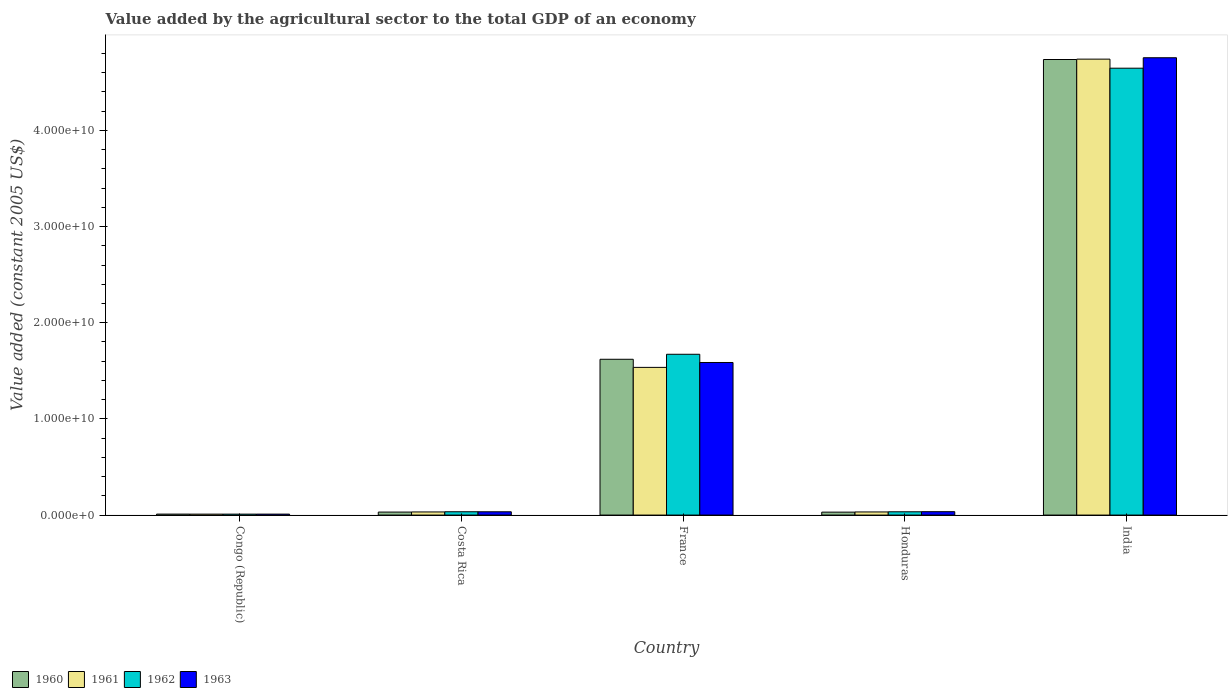Are the number of bars on each tick of the X-axis equal?
Keep it short and to the point. Yes. How many bars are there on the 1st tick from the right?
Your response must be concise. 4. What is the label of the 5th group of bars from the left?
Provide a short and direct response. India. In how many cases, is the number of bars for a given country not equal to the number of legend labels?
Give a very brief answer. 0. What is the value added by the agricultural sector in 1963 in Costa Rica?
Offer a terse response. 3.43e+08. Across all countries, what is the maximum value added by the agricultural sector in 1963?
Your answer should be compact. 4.76e+1. Across all countries, what is the minimum value added by the agricultural sector in 1962?
Offer a terse response. 9.79e+07. In which country was the value added by the agricultural sector in 1963 minimum?
Your response must be concise. Congo (Republic). What is the total value added by the agricultural sector in 1962 in the graph?
Provide a short and direct response. 6.40e+1. What is the difference between the value added by the agricultural sector in 1963 in Costa Rica and that in Honduras?
Your response must be concise. -9.78e+06. What is the difference between the value added by the agricultural sector in 1960 in Honduras and the value added by the agricultural sector in 1961 in France?
Your answer should be compact. -1.51e+1. What is the average value added by the agricultural sector in 1963 per country?
Offer a very short reply. 1.28e+1. What is the difference between the value added by the agricultural sector of/in 1962 and value added by the agricultural sector of/in 1960 in Honduras?
Provide a succinct answer. 3.54e+07. In how many countries, is the value added by the agricultural sector in 1962 greater than 6000000000 US$?
Your response must be concise. 2. What is the ratio of the value added by the agricultural sector in 1961 in France to that in Honduras?
Your answer should be very brief. 47.21. What is the difference between the highest and the second highest value added by the agricultural sector in 1960?
Offer a very short reply. 3.12e+1. What is the difference between the highest and the lowest value added by the agricultural sector in 1963?
Keep it short and to the point. 4.75e+1. In how many countries, is the value added by the agricultural sector in 1962 greater than the average value added by the agricultural sector in 1962 taken over all countries?
Your response must be concise. 2. What does the 1st bar from the left in India represents?
Keep it short and to the point. 1960. Is it the case that in every country, the sum of the value added by the agricultural sector in 1961 and value added by the agricultural sector in 1960 is greater than the value added by the agricultural sector in 1963?
Provide a succinct answer. Yes. Are all the bars in the graph horizontal?
Provide a succinct answer. No. How many countries are there in the graph?
Keep it short and to the point. 5. What is the title of the graph?
Your answer should be very brief. Value added by the agricultural sector to the total GDP of an economy. Does "1983" appear as one of the legend labels in the graph?
Make the answer very short. No. What is the label or title of the Y-axis?
Ensure brevity in your answer.  Value added (constant 2005 US$). What is the Value added (constant 2005 US$) of 1960 in Congo (Republic)?
Ensure brevity in your answer.  1.01e+08. What is the Value added (constant 2005 US$) of 1961 in Congo (Republic)?
Your answer should be compact. 9.74e+07. What is the Value added (constant 2005 US$) in 1962 in Congo (Republic)?
Provide a short and direct response. 9.79e+07. What is the Value added (constant 2005 US$) in 1963 in Congo (Republic)?
Your answer should be compact. 9.86e+07. What is the Value added (constant 2005 US$) of 1960 in Costa Rica?
Give a very brief answer. 3.13e+08. What is the Value added (constant 2005 US$) of 1961 in Costa Rica?
Your answer should be very brief. 3.24e+08. What is the Value added (constant 2005 US$) in 1962 in Costa Rica?
Give a very brief answer. 3.44e+08. What is the Value added (constant 2005 US$) in 1963 in Costa Rica?
Make the answer very short. 3.43e+08. What is the Value added (constant 2005 US$) of 1960 in France?
Provide a succinct answer. 1.62e+1. What is the Value added (constant 2005 US$) of 1961 in France?
Offer a terse response. 1.54e+1. What is the Value added (constant 2005 US$) of 1962 in France?
Your answer should be compact. 1.67e+1. What is the Value added (constant 2005 US$) in 1963 in France?
Make the answer very short. 1.59e+1. What is the Value added (constant 2005 US$) of 1960 in Honduras?
Ensure brevity in your answer.  3.05e+08. What is the Value added (constant 2005 US$) in 1961 in Honduras?
Your response must be concise. 3.25e+08. What is the Value added (constant 2005 US$) of 1962 in Honduras?
Your response must be concise. 3.41e+08. What is the Value added (constant 2005 US$) of 1963 in Honduras?
Offer a terse response. 3.53e+08. What is the Value added (constant 2005 US$) of 1960 in India?
Give a very brief answer. 4.74e+1. What is the Value added (constant 2005 US$) in 1961 in India?
Give a very brief answer. 4.74e+1. What is the Value added (constant 2005 US$) in 1962 in India?
Provide a short and direct response. 4.65e+1. What is the Value added (constant 2005 US$) of 1963 in India?
Provide a short and direct response. 4.76e+1. Across all countries, what is the maximum Value added (constant 2005 US$) in 1960?
Provide a short and direct response. 4.74e+1. Across all countries, what is the maximum Value added (constant 2005 US$) in 1961?
Give a very brief answer. 4.74e+1. Across all countries, what is the maximum Value added (constant 2005 US$) in 1962?
Offer a very short reply. 4.65e+1. Across all countries, what is the maximum Value added (constant 2005 US$) in 1963?
Your response must be concise. 4.76e+1. Across all countries, what is the minimum Value added (constant 2005 US$) in 1960?
Ensure brevity in your answer.  1.01e+08. Across all countries, what is the minimum Value added (constant 2005 US$) in 1961?
Your response must be concise. 9.74e+07. Across all countries, what is the minimum Value added (constant 2005 US$) of 1962?
Ensure brevity in your answer.  9.79e+07. Across all countries, what is the minimum Value added (constant 2005 US$) in 1963?
Offer a terse response. 9.86e+07. What is the total Value added (constant 2005 US$) in 1960 in the graph?
Provide a short and direct response. 6.43e+1. What is the total Value added (constant 2005 US$) in 1961 in the graph?
Make the answer very short. 6.35e+1. What is the total Value added (constant 2005 US$) of 1962 in the graph?
Offer a very short reply. 6.40e+1. What is the total Value added (constant 2005 US$) in 1963 in the graph?
Your answer should be compact. 6.42e+1. What is the difference between the Value added (constant 2005 US$) in 1960 in Congo (Republic) and that in Costa Rica?
Ensure brevity in your answer.  -2.12e+08. What is the difference between the Value added (constant 2005 US$) in 1961 in Congo (Republic) and that in Costa Rica?
Your answer should be very brief. -2.27e+08. What is the difference between the Value added (constant 2005 US$) in 1962 in Congo (Republic) and that in Costa Rica?
Make the answer very short. -2.46e+08. What is the difference between the Value added (constant 2005 US$) in 1963 in Congo (Republic) and that in Costa Rica?
Give a very brief answer. -2.45e+08. What is the difference between the Value added (constant 2005 US$) of 1960 in Congo (Republic) and that in France?
Keep it short and to the point. -1.61e+1. What is the difference between the Value added (constant 2005 US$) in 1961 in Congo (Republic) and that in France?
Make the answer very short. -1.53e+1. What is the difference between the Value added (constant 2005 US$) of 1962 in Congo (Republic) and that in France?
Keep it short and to the point. -1.66e+1. What is the difference between the Value added (constant 2005 US$) of 1963 in Congo (Republic) and that in France?
Your response must be concise. -1.58e+1. What is the difference between the Value added (constant 2005 US$) of 1960 in Congo (Republic) and that in Honduras?
Your answer should be very brief. -2.04e+08. What is the difference between the Value added (constant 2005 US$) of 1961 in Congo (Republic) and that in Honduras?
Your answer should be very brief. -2.28e+08. What is the difference between the Value added (constant 2005 US$) in 1962 in Congo (Republic) and that in Honduras?
Offer a terse response. -2.43e+08. What is the difference between the Value added (constant 2005 US$) of 1963 in Congo (Republic) and that in Honduras?
Your answer should be very brief. -2.55e+08. What is the difference between the Value added (constant 2005 US$) of 1960 in Congo (Republic) and that in India?
Your answer should be very brief. -4.73e+1. What is the difference between the Value added (constant 2005 US$) of 1961 in Congo (Republic) and that in India?
Your response must be concise. -4.73e+1. What is the difference between the Value added (constant 2005 US$) of 1962 in Congo (Republic) and that in India?
Your answer should be compact. -4.64e+1. What is the difference between the Value added (constant 2005 US$) in 1963 in Congo (Republic) and that in India?
Offer a very short reply. -4.75e+1. What is the difference between the Value added (constant 2005 US$) in 1960 in Costa Rica and that in France?
Your response must be concise. -1.59e+1. What is the difference between the Value added (constant 2005 US$) in 1961 in Costa Rica and that in France?
Offer a very short reply. -1.50e+1. What is the difference between the Value added (constant 2005 US$) in 1962 in Costa Rica and that in France?
Your response must be concise. -1.64e+1. What is the difference between the Value added (constant 2005 US$) of 1963 in Costa Rica and that in France?
Provide a short and direct response. -1.55e+1. What is the difference between the Value added (constant 2005 US$) in 1960 in Costa Rica and that in Honduras?
Provide a succinct answer. 7.61e+06. What is the difference between the Value added (constant 2005 US$) of 1961 in Costa Rica and that in Honduras?
Provide a succinct answer. -8.14e+05. What is the difference between the Value added (constant 2005 US$) in 1962 in Costa Rica and that in Honduras?
Ensure brevity in your answer.  3.61e+06. What is the difference between the Value added (constant 2005 US$) in 1963 in Costa Rica and that in Honduras?
Offer a terse response. -9.78e+06. What is the difference between the Value added (constant 2005 US$) of 1960 in Costa Rica and that in India?
Your answer should be compact. -4.71e+1. What is the difference between the Value added (constant 2005 US$) of 1961 in Costa Rica and that in India?
Your answer should be very brief. -4.71e+1. What is the difference between the Value added (constant 2005 US$) in 1962 in Costa Rica and that in India?
Make the answer very short. -4.61e+1. What is the difference between the Value added (constant 2005 US$) of 1963 in Costa Rica and that in India?
Your response must be concise. -4.72e+1. What is the difference between the Value added (constant 2005 US$) of 1960 in France and that in Honduras?
Your answer should be compact. 1.59e+1. What is the difference between the Value added (constant 2005 US$) of 1961 in France and that in Honduras?
Your answer should be compact. 1.50e+1. What is the difference between the Value added (constant 2005 US$) in 1962 in France and that in Honduras?
Offer a terse response. 1.64e+1. What is the difference between the Value added (constant 2005 US$) in 1963 in France and that in Honduras?
Give a very brief answer. 1.55e+1. What is the difference between the Value added (constant 2005 US$) of 1960 in France and that in India?
Make the answer very short. -3.12e+1. What is the difference between the Value added (constant 2005 US$) of 1961 in France and that in India?
Keep it short and to the point. -3.21e+1. What is the difference between the Value added (constant 2005 US$) in 1962 in France and that in India?
Your answer should be very brief. -2.97e+1. What is the difference between the Value added (constant 2005 US$) in 1963 in France and that in India?
Offer a terse response. -3.17e+1. What is the difference between the Value added (constant 2005 US$) of 1960 in Honduras and that in India?
Your answer should be compact. -4.71e+1. What is the difference between the Value added (constant 2005 US$) in 1961 in Honduras and that in India?
Your answer should be very brief. -4.71e+1. What is the difference between the Value added (constant 2005 US$) in 1962 in Honduras and that in India?
Give a very brief answer. -4.61e+1. What is the difference between the Value added (constant 2005 US$) in 1963 in Honduras and that in India?
Offer a terse response. -4.72e+1. What is the difference between the Value added (constant 2005 US$) in 1960 in Congo (Republic) and the Value added (constant 2005 US$) in 1961 in Costa Rica?
Your answer should be very brief. -2.24e+08. What is the difference between the Value added (constant 2005 US$) of 1960 in Congo (Republic) and the Value added (constant 2005 US$) of 1962 in Costa Rica?
Your response must be concise. -2.43e+08. What is the difference between the Value added (constant 2005 US$) in 1960 in Congo (Republic) and the Value added (constant 2005 US$) in 1963 in Costa Rica?
Keep it short and to the point. -2.42e+08. What is the difference between the Value added (constant 2005 US$) of 1961 in Congo (Republic) and the Value added (constant 2005 US$) of 1962 in Costa Rica?
Your answer should be compact. -2.47e+08. What is the difference between the Value added (constant 2005 US$) in 1961 in Congo (Republic) and the Value added (constant 2005 US$) in 1963 in Costa Rica?
Make the answer very short. -2.46e+08. What is the difference between the Value added (constant 2005 US$) of 1962 in Congo (Republic) and the Value added (constant 2005 US$) of 1963 in Costa Rica?
Make the answer very short. -2.45e+08. What is the difference between the Value added (constant 2005 US$) in 1960 in Congo (Republic) and the Value added (constant 2005 US$) in 1961 in France?
Your response must be concise. -1.53e+1. What is the difference between the Value added (constant 2005 US$) of 1960 in Congo (Republic) and the Value added (constant 2005 US$) of 1962 in France?
Provide a succinct answer. -1.66e+1. What is the difference between the Value added (constant 2005 US$) of 1960 in Congo (Republic) and the Value added (constant 2005 US$) of 1963 in France?
Your answer should be compact. -1.58e+1. What is the difference between the Value added (constant 2005 US$) of 1961 in Congo (Republic) and the Value added (constant 2005 US$) of 1962 in France?
Your answer should be compact. -1.66e+1. What is the difference between the Value added (constant 2005 US$) in 1961 in Congo (Republic) and the Value added (constant 2005 US$) in 1963 in France?
Your response must be concise. -1.58e+1. What is the difference between the Value added (constant 2005 US$) of 1962 in Congo (Republic) and the Value added (constant 2005 US$) of 1963 in France?
Your answer should be compact. -1.58e+1. What is the difference between the Value added (constant 2005 US$) of 1960 in Congo (Republic) and the Value added (constant 2005 US$) of 1961 in Honduras?
Make the answer very short. -2.24e+08. What is the difference between the Value added (constant 2005 US$) of 1960 in Congo (Republic) and the Value added (constant 2005 US$) of 1962 in Honduras?
Ensure brevity in your answer.  -2.40e+08. What is the difference between the Value added (constant 2005 US$) of 1960 in Congo (Republic) and the Value added (constant 2005 US$) of 1963 in Honduras?
Give a very brief answer. -2.52e+08. What is the difference between the Value added (constant 2005 US$) in 1961 in Congo (Republic) and the Value added (constant 2005 US$) in 1962 in Honduras?
Give a very brief answer. -2.43e+08. What is the difference between the Value added (constant 2005 US$) in 1961 in Congo (Republic) and the Value added (constant 2005 US$) in 1963 in Honduras?
Ensure brevity in your answer.  -2.56e+08. What is the difference between the Value added (constant 2005 US$) in 1962 in Congo (Republic) and the Value added (constant 2005 US$) in 1963 in Honduras?
Your answer should be compact. -2.55e+08. What is the difference between the Value added (constant 2005 US$) in 1960 in Congo (Republic) and the Value added (constant 2005 US$) in 1961 in India?
Ensure brevity in your answer.  -4.73e+1. What is the difference between the Value added (constant 2005 US$) in 1960 in Congo (Republic) and the Value added (constant 2005 US$) in 1962 in India?
Provide a short and direct response. -4.64e+1. What is the difference between the Value added (constant 2005 US$) in 1960 in Congo (Republic) and the Value added (constant 2005 US$) in 1963 in India?
Offer a very short reply. -4.75e+1. What is the difference between the Value added (constant 2005 US$) of 1961 in Congo (Republic) and the Value added (constant 2005 US$) of 1962 in India?
Give a very brief answer. -4.64e+1. What is the difference between the Value added (constant 2005 US$) of 1961 in Congo (Republic) and the Value added (constant 2005 US$) of 1963 in India?
Provide a succinct answer. -4.75e+1. What is the difference between the Value added (constant 2005 US$) of 1962 in Congo (Republic) and the Value added (constant 2005 US$) of 1963 in India?
Make the answer very short. -4.75e+1. What is the difference between the Value added (constant 2005 US$) in 1960 in Costa Rica and the Value added (constant 2005 US$) in 1961 in France?
Ensure brevity in your answer.  -1.50e+1. What is the difference between the Value added (constant 2005 US$) of 1960 in Costa Rica and the Value added (constant 2005 US$) of 1962 in France?
Your response must be concise. -1.64e+1. What is the difference between the Value added (constant 2005 US$) in 1960 in Costa Rica and the Value added (constant 2005 US$) in 1963 in France?
Ensure brevity in your answer.  -1.56e+1. What is the difference between the Value added (constant 2005 US$) of 1961 in Costa Rica and the Value added (constant 2005 US$) of 1962 in France?
Provide a short and direct response. -1.64e+1. What is the difference between the Value added (constant 2005 US$) in 1961 in Costa Rica and the Value added (constant 2005 US$) in 1963 in France?
Your response must be concise. -1.55e+1. What is the difference between the Value added (constant 2005 US$) in 1962 in Costa Rica and the Value added (constant 2005 US$) in 1963 in France?
Give a very brief answer. -1.55e+1. What is the difference between the Value added (constant 2005 US$) in 1960 in Costa Rica and the Value added (constant 2005 US$) in 1961 in Honduras?
Your answer should be compact. -1.23e+07. What is the difference between the Value added (constant 2005 US$) of 1960 in Costa Rica and the Value added (constant 2005 US$) of 1962 in Honduras?
Make the answer very short. -2.78e+07. What is the difference between the Value added (constant 2005 US$) of 1960 in Costa Rica and the Value added (constant 2005 US$) of 1963 in Honduras?
Make the answer very short. -4.02e+07. What is the difference between the Value added (constant 2005 US$) of 1961 in Costa Rica and the Value added (constant 2005 US$) of 1962 in Honduras?
Offer a terse response. -1.63e+07. What is the difference between the Value added (constant 2005 US$) of 1961 in Costa Rica and the Value added (constant 2005 US$) of 1963 in Honduras?
Give a very brief answer. -2.87e+07. What is the difference between the Value added (constant 2005 US$) of 1962 in Costa Rica and the Value added (constant 2005 US$) of 1963 in Honduras?
Make the answer very short. -8.78e+06. What is the difference between the Value added (constant 2005 US$) of 1960 in Costa Rica and the Value added (constant 2005 US$) of 1961 in India?
Offer a very short reply. -4.71e+1. What is the difference between the Value added (constant 2005 US$) of 1960 in Costa Rica and the Value added (constant 2005 US$) of 1962 in India?
Ensure brevity in your answer.  -4.62e+1. What is the difference between the Value added (constant 2005 US$) in 1960 in Costa Rica and the Value added (constant 2005 US$) in 1963 in India?
Provide a succinct answer. -4.72e+1. What is the difference between the Value added (constant 2005 US$) in 1961 in Costa Rica and the Value added (constant 2005 US$) in 1962 in India?
Provide a short and direct response. -4.61e+1. What is the difference between the Value added (constant 2005 US$) in 1961 in Costa Rica and the Value added (constant 2005 US$) in 1963 in India?
Provide a short and direct response. -4.72e+1. What is the difference between the Value added (constant 2005 US$) of 1962 in Costa Rica and the Value added (constant 2005 US$) of 1963 in India?
Make the answer very short. -4.72e+1. What is the difference between the Value added (constant 2005 US$) of 1960 in France and the Value added (constant 2005 US$) of 1961 in Honduras?
Your answer should be very brief. 1.59e+1. What is the difference between the Value added (constant 2005 US$) in 1960 in France and the Value added (constant 2005 US$) in 1962 in Honduras?
Give a very brief answer. 1.59e+1. What is the difference between the Value added (constant 2005 US$) in 1960 in France and the Value added (constant 2005 US$) in 1963 in Honduras?
Provide a succinct answer. 1.58e+1. What is the difference between the Value added (constant 2005 US$) in 1961 in France and the Value added (constant 2005 US$) in 1962 in Honduras?
Ensure brevity in your answer.  1.50e+1. What is the difference between the Value added (constant 2005 US$) of 1961 in France and the Value added (constant 2005 US$) of 1963 in Honduras?
Your response must be concise. 1.50e+1. What is the difference between the Value added (constant 2005 US$) in 1962 in France and the Value added (constant 2005 US$) in 1963 in Honduras?
Provide a succinct answer. 1.64e+1. What is the difference between the Value added (constant 2005 US$) of 1960 in France and the Value added (constant 2005 US$) of 1961 in India?
Provide a succinct answer. -3.12e+1. What is the difference between the Value added (constant 2005 US$) of 1960 in France and the Value added (constant 2005 US$) of 1962 in India?
Offer a terse response. -3.03e+1. What is the difference between the Value added (constant 2005 US$) of 1960 in France and the Value added (constant 2005 US$) of 1963 in India?
Provide a succinct answer. -3.14e+1. What is the difference between the Value added (constant 2005 US$) in 1961 in France and the Value added (constant 2005 US$) in 1962 in India?
Offer a very short reply. -3.11e+1. What is the difference between the Value added (constant 2005 US$) of 1961 in France and the Value added (constant 2005 US$) of 1963 in India?
Ensure brevity in your answer.  -3.22e+1. What is the difference between the Value added (constant 2005 US$) of 1962 in France and the Value added (constant 2005 US$) of 1963 in India?
Ensure brevity in your answer.  -3.08e+1. What is the difference between the Value added (constant 2005 US$) in 1960 in Honduras and the Value added (constant 2005 US$) in 1961 in India?
Ensure brevity in your answer.  -4.71e+1. What is the difference between the Value added (constant 2005 US$) of 1960 in Honduras and the Value added (constant 2005 US$) of 1962 in India?
Your response must be concise. -4.62e+1. What is the difference between the Value added (constant 2005 US$) of 1960 in Honduras and the Value added (constant 2005 US$) of 1963 in India?
Your answer should be compact. -4.72e+1. What is the difference between the Value added (constant 2005 US$) of 1961 in Honduras and the Value added (constant 2005 US$) of 1962 in India?
Keep it short and to the point. -4.61e+1. What is the difference between the Value added (constant 2005 US$) in 1961 in Honduras and the Value added (constant 2005 US$) in 1963 in India?
Ensure brevity in your answer.  -4.72e+1. What is the difference between the Value added (constant 2005 US$) in 1962 in Honduras and the Value added (constant 2005 US$) in 1963 in India?
Your answer should be very brief. -4.72e+1. What is the average Value added (constant 2005 US$) of 1960 per country?
Your answer should be very brief. 1.29e+1. What is the average Value added (constant 2005 US$) of 1961 per country?
Offer a very short reply. 1.27e+1. What is the average Value added (constant 2005 US$) in 1962 per country?
Offer a terse response. 1.28e+1. What is the average Value added (constant 2005 US$) in 1963 per country?
Offer a very short reply. 1.28e+1. What is the difference between the Value added (constant 2005 US$) in 1960 and Value added (constant 2005 US$) in 1961 in Congo (Republic)?
Make the answer very short. 3.61e+06. What is the difference between the Value added (constant 2005 US$) in 1960 and Value added (constant 2005 US$) in 1962 in Congo (Republic)?
Provide a succinct answer. 3.02e+06. What is the difference between the Value added (constant 2005 US$) in 1960 and Value added (constant 2005 US$) in 1963 in Congo (Republic)?
Offer a very short reply. 2.34e+06. What is the difference between the Value added (constant 2005 US$) in 1961 and Value added (constant 2005 US$) in 1962 in Congo (Republic)?
Ensure brevity in your answer.  -5.86e+05. What is the difference between the Value added (constant 2005 US$) of 1961 and Value added (constant 2005 US$) of 1963 in Congo (Republic)?
Your answer should be very brief. -1.27e+06. What is the difference between the Value added (constant 2005 US$) of 1962 and Value added (constant 2005 US$) of 1963 in Congo (Republic)?
Ensure brevity in your answer.  -6.85e+05. What is the difference between the Value added (constant 2005 US$) in 1960 and Value added (constant 2005 US$) in 1961 in Costa Rica?
Offer a very short reply. -1.15e+07. What is the difference between the Value added (constant 2005 US$) of 1960 and Value added (constant 2005 US$) of 1962 in Costa Rica?
Give a very brief answer. -3.14e+07. What is the difference between the Value added (constant 2005 US$) of 1960 and Value added (constant 2005 US$) of 1963 in Costa Rica?
Offer a very short reply. -3.04e+07. What is the difference between the Value added (constant 2005 US$) of 1961 and Value added (constant 2005 US$) of 1962 in Costa Rica?
Your answer should be compact. -1.99e+07. What is the difference between the Value added (constant 2005 US$) of 1961 and Value added (constant 2005 US$) of 1963 in Costa Rica?
Offer a very short reply. -1.89e+07. What is the difference between the Value added (constant 2005 US$) of 1962 and Value added (constant 2005 US$) of 1963 in Costa Rica?
Ensure brevity in your answer.  1.00e+06. What is the difference between the Value added (constant 2005 US$) of 1960 and Value added (constant 2005 US$) of 1961 in France?
Your answer should be compact. 8.42e+08. What is the difference between the Value added (constant 2005 US$) of 1960 and Value added (constant 2005 US$) of 1962 in France?
Provide a succinct answer. -5.20e+08. What is the difference between the Value added (constant 2005 US$) in 1960 and Value added (constant 2005 US$) in 1963 in France?
Make the answer very short. 3.35e+08. What is the difference between the Value added (constant 2005 US$) of 1961 and Value added (constant 2005 US$) of 1962 in France?
Give a very brief answer. -1.36e+09. What is the difference between the Value added (constant 2005 US$) of 1961 and Value added (constant 2005 US$) of 1963 in France?
Keep it short and to the point. -5.07e+08. What is the difference between the Value added (constant 2005 US$) in 1962 and Value added (constant 2005 US$) in 1963 in France?
Keep it short and to the point. 8.56e+08. What is the difference between the Value added (constant 2005 US$) of 1960 and Value added (constant 2005 US$) of 1961 in Honduras?
Your answer should be compact. -1.99e+07. What is the difference between the Value added (constant 2005 US$) of 1960 and Value added (constant 2005 US$) of 1962 in Honduras?
Your answer should be very brief. -3.54e+07. What is the difference between the Value added (constant 2005 US$) of 1960 and Value added (constant 2005 US$) of 1963 in Honduras?
Keep it short and to the point. -4.78e+07. What is the difference between the Value added (constant 2005 US$) of 1961 and Value added (constant 2005 US$) of 1962 in Honduras?
Ensure brevity in your answer.  -1.55e+07. What is the difference between the Value added (constant 2005 US$) in 1961 and Value added (constant 2005 US$) in 1963 in Honduras?
Provide a succinct answer. -2.79e+07. What is the difference between the Value added (constant 2005 US$) in 1962 and Value added (constant 2005 US$) in 1963 in Honduras?
Your response must be concise. -1.24e+07. What is the difference between the Value added (constant 2005 US$) of 1960 and Value added (constant 2005 US$) of 1961 in India?
Give a very brief answer. -3.99e+07. What is the difference between the Value added (constant 2005 US$) in 1960 and Value added (constant 2005 US$) in 1962 in India?
Ensure brevity in your answer.  9.03e+08. What is the difference between the Value added (constant 2005 US$) of 1960 and Value added (constant 2005 US$) of 1963 in India?
Offer a terse response. -1.84e+08. What is the difference between the Value added (constant 2005 US$) in 1961 and Value added (constant 2005 US$) in 1962 in India?
Provide a succinct answer. 9.43e+08. What is the difference between the Value added (constant 2005 US$) of 1961 and Value added (constant 2005 US$) of 1963 in India?
Your response must be concise. -1.44e+08. What is the difference between the Value added (constant 2005 US$) in 1962 and Value added (constant 2005 US$) in 1963 in India?
Make the answer very short. -1.09e+09. What is the ratio of the Value added (constant 2005 US$) of 1960 in Congo (Republic) to that in Costa Rica?
Your answer should be very brief. 0.32. What is the ratio of the Value added (constant 2005 US$) of 1962 in Congo (Republic) to that in Costa Rica?
Keep it short and to the point. 0.28. What is the ratio of the Value added (constant 2005 US$) of 1963 in Congo (Republic) to that in Costa Rica?
Offer a very short reply. 0.29. What is the ratio of the Value added (constant 2005 US$) in 1960 in Congo (Republic) to that in France?
Your answer should be very brief. 0.01. What is the ratio of the Value added (constant 2005 US$) in 1961 in Congo (Republic) to that in France?
Keep it short and to the point. 0.01. What is the ratio of the Value added (constant 2005 US$) in 1962 in Congo (Republic) to that in France?
Offer a very short reply. 0.01. What is the ratio of the Value added (constant 2005 US$) of 1963 in Congo (Republic) to that in France?
Ensure brevity in your answer.  0.01. What is the ratio of the Value added (constant 2005 US$) in 1960 in Congo (Republic) to that in Honduras?
Offer a terse response. 0.33. What is the ratio of the Value added (constant 2005 US$) of 1961 in Congo (Republic) to that in Honduras?
Make the answer very short. 0.3. What is the ratio of the Value added (constant 2005 US$) in 1962 in Congo (Republic) to that in Honduras?
Offer a very short reply. 0.29. What is the ratio of the Value added (constant 2005 US$) in 1963 in Congo (Republic) to that in Honduras?
Your answer should be very brief. 0.28. What is the ratio of the Value added (constant 2005 US$) in 1960 in Congo (Republic) to that in India?
Offer a very short reply. 0. What is the ratio of the Value added (constant 2005 US$) in 1961 in Congo (Republic) to that in India?
Keep it short and to the point. 0. What is the ratio of the Value added (constant 2005 US$) in 1962 in Congo (Republic) to that in India?
Make the answer very short. 0. What is the ratio of the Value added (constant 2005 US$) in 1963 in Congo (Republic) to that in India?
Give a very brief answer. 0. What is the ratio of the Value added (constant 2005 US$) of 1960 in Costa Rica to that in France?
Ensure brevity in your answer.  0.02. What is the ratio of the Value added (constant 2005 US$) in 1961 in Costa Rica to that in France?
Offer a very short reply. 0.02. What is the ratio of the Value added (constant 2005 US$) in 1962 in Costa Rica to that in France?
Your response must be concise. 0.02. What is the ratio of the Value added (constant 2005 US$) of 1963 in Costa Rica to that in France?
Provide a succinct answer. 0.02. What is the ratio of the Value added (constant 2005 US$) in 1960 in Costa Rica to that in Honduras?
Provide a short and direct response. 1.02. What is the ratio of the Value added (constant 2005 US$) in 1961 in Costa Rica to that in Honduras?
Make the answer very short. 1. What is the ratio of the Value added (constant 2005 US$) of 1962 in Costa Rica to that in Honduras?
Your response must be concise. 1.01. What is the ratio of the Value added (constant 2005 US$) in 1963 in Costa Rica to that in Honduras?
Provide a succinct answer. 0.97. What is the ratio of the Value added (constant 2005 US$) of 1960 in Costa Rica to that in India?
Provide a short and direct response. 0.01. What is the ratio of the Value added (constant 2005 US$) in 1961 in Costa Rica to that in India?
Your answer should be compact. 0.01. What is the ratio of the Value added (constant 2005 US$) of 1962 in Costa Rica to that in India?
Your answer should be compact. 0.01. What is the ratio of the Value added (constant 2005 US$) in 1963 in Costa Rica to that in India?
Make the answer very short. 0.01. What is the ratio of the Value added (constant 2005 US$) of 1960 in France to that in Honduras?
Ensure brevity in your answer.  53.05. What is the ratio of the Value added (constant 2005 US$) of 1961 in France to that in Honduras?
Offer a very short reply. 47.21. What is the ratio of the Value added (constant 2005 US$) in 1962 in France to that in Honduras?
Offer a very short reply. 49.07. What is the ratio of the Value added (constant 2005 US$) of 1963 in France to that in Honduras?
Make the answer very short. 44.92. What is the ratio of the Value added (constant 2005 US$) of 1960 in France to that in India?
Make the answer very short. 0.34. What is the ratio of the Value added (constant 2005 US$) in 1961 in France to that in India?
Your response must be concise. 0.32. What is the ratio of the Value added (constant 2005 US$) in 1962 in France to that in India?
Your answer should be very brief. 0.36. What is the ratio of the Value added (constant 2005 US$) of 1963 in France to that in India?
Offer a very short reply. 0.33. What is the ratio of the Value added (constant 2005 US$) of 1960 in Honduras to that in India?
Provide a succinct answer. 0.01. What is the ratio of the Value added (constant 2005 US$) in 1961 in Honduras to that in India?
Your answer should be very brief. 0.01. What is the ratio of the Value added (constant 2005 US$) of 1962 in Honduras to that in India?
Give a very brief answer. 0.01. What is the ratio of the Value added (constant 2005 US$) in 1963 in Honduras to that in India?
Your answer should be compact. 0.01. What is the difference between the highest and the second highest Value added (constant 2005 US$) of 1960?
Your answer should be compact. 3.12e+1. What is the difference between the highest and the second highest Value added (constant 2005 US$) of 1961?
Provide a succinct answer. 3.21e+1. What is the difference between the highest and the second highest Value added (constant 2005 US$) of 1962?
Provide a short and direct response. 2.97e+1. What is the difference between the highest and the second highest Value added (constant 2005 US$) of 1963?
Provide a short and direct response. 3.17e+1. What is the difference between the highest and the lowest Value added (constant 2005 US$) in 1960?
Offer a terse response. 4.73e+1. What is the difference between the highest and the lowest Value added (constant 2005 US$) of 1961?
Provide a short and direct response. 4.73e+1. What is the difference between the highest and the lowest Value added (constant 2005 US$) in 1962?
Provide a short and direct response. 4.64e+1. What is the difference between the highest and the lowest Value added (constant 2005 US$) of 1963?
Make the answer very short. 4.75e+1. 